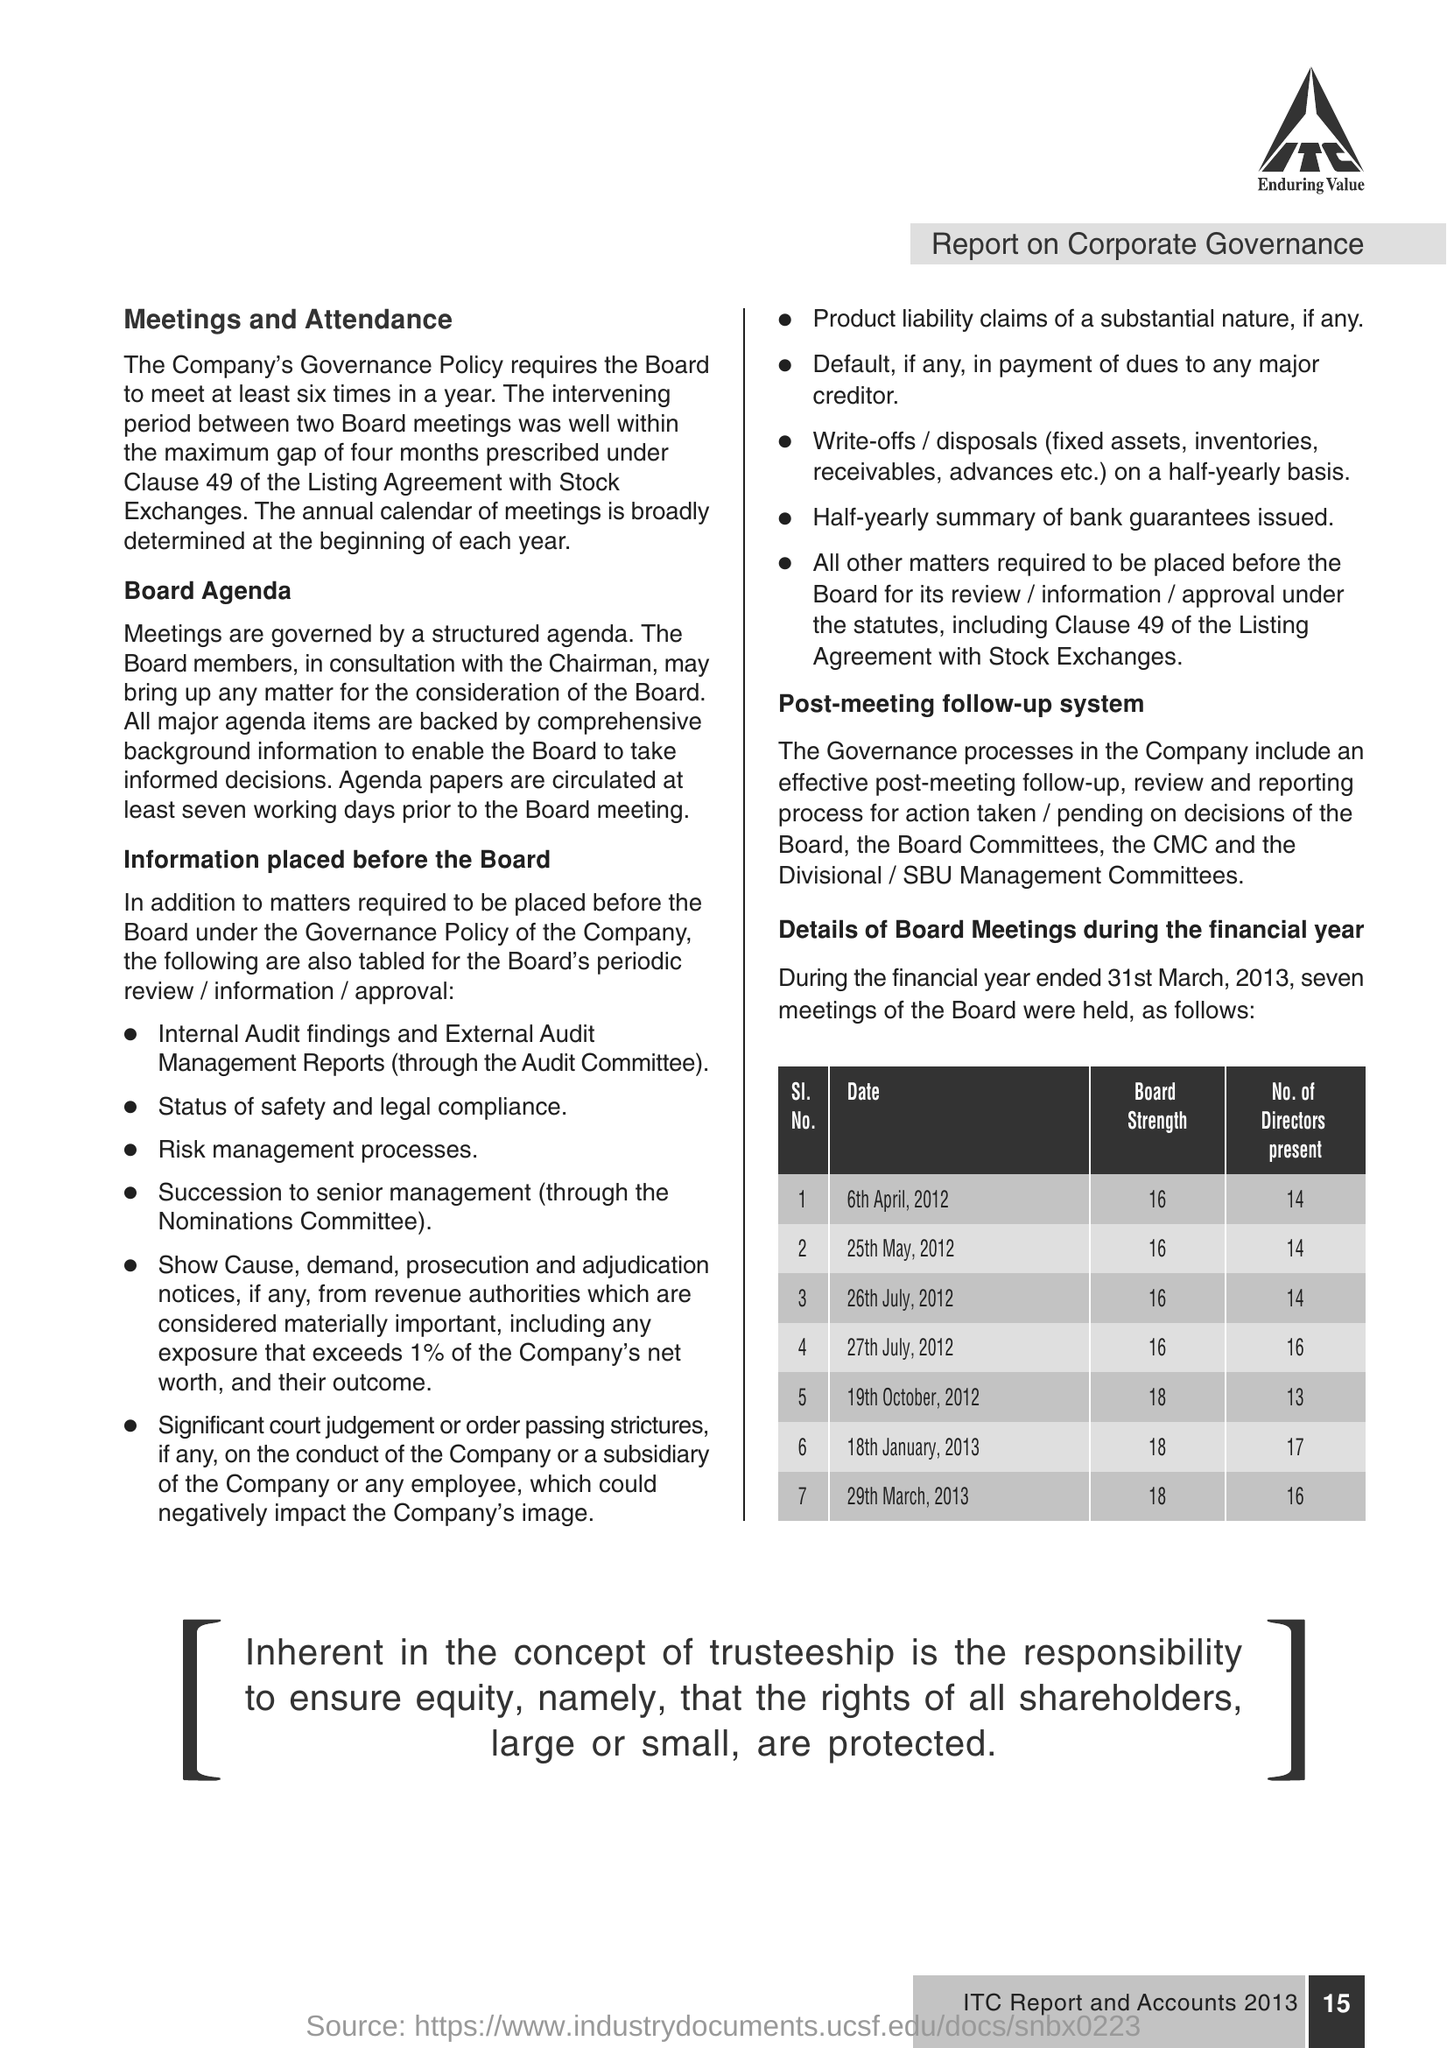How many Directors were present on board meeting  of 6th April,2012
Ensure brevity in your answer.  14. 